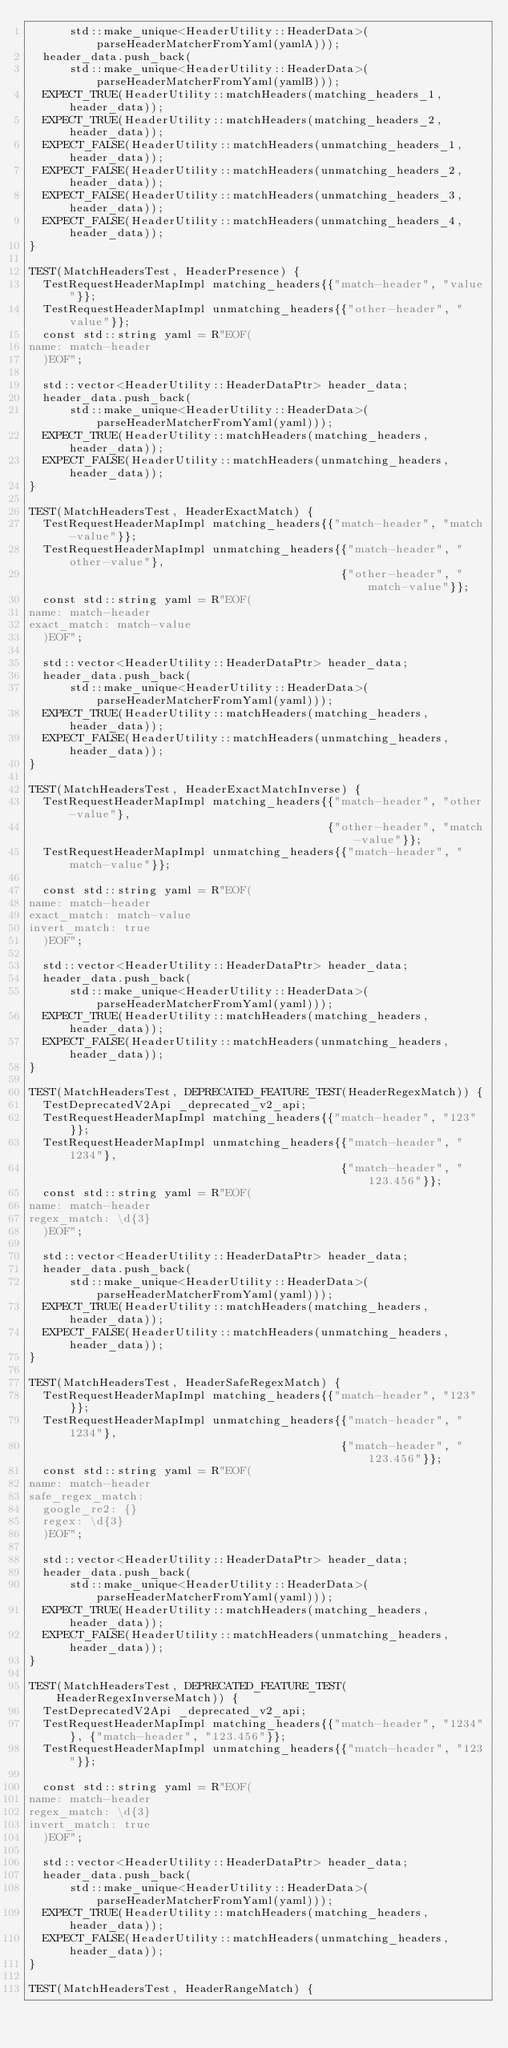Convert code to text. <code><loc_0><loc_0><loc_500><loc_500><_C++_>      std::make_unique<HeaderUtility::HeaderData>(parseHeaderMatcherFromYaml(yamlA)));
  header_data.push_back(
      std::make_unique<HeaderUtility::HeaderData>(parseHeaderMatcherFromYaml(yamlB)));
  EXPECT_TRUE(HeaderUtility::matchHeaders(matching_headers_1, header_data));
  EXPECT_TRUE(HeaderUtility::matchHeaders(matching_headers_2, header_data));
  EXPECT_FALSE(HeaderUtility::matchHeaders(unmatching_headers_1, header_data));
  EXPECT_FALSE(HeaderUtility::matchHeaders(unmatching_headers_2, header_data));
  EXPECT_FALSE(HeaderUtility::matchHeaders(unmatching_headers_3, header_data));
  EXPECT_FALSE(HeaderUtility::matchHeaders(unmatching_headers_4, header_data));
}

TEST(MatchHeadersTest, HeaderPresence) {
  TestRequestHeaderMapImpl matching_headers{{"match-header", "value"}};
  TestRequestHeaderMapImpl unmatching_headers{{"other-header", "value"}};
  const std::string yaml = R"EOF(
name: match-header
  )EOF";

  std::vector<HeaderUtility::HeaderDataPtr> header_data;
  header_data.push_back(
      std::make_unique<HeaderUtility::HeaderData>(parseHeaderMatcherFromYaml(yaml)));
  EXPECT_TRUE(HeaderUtility::matchHeaders(matching_headers, header_data));
  EXPECT_FALSE(HeaderUtility::matchHeaders(unmatching_headers, header_data));
}

TEST(MatchHeadersTest, HeaderExactMatch) {
  TestRequestHeaderMapImpl matching_headers{{"match-header", "match-value"}};
  TestRequestHeaderMapImpl unmatching_headers{{"match-header", "other-value"},
                                              {"other-header", "match-value"}};
  const std::string yaml = R"EOF(
name: match-header
exact_match: match-value
  )EOF";

  std::vector<HeaderUtility::HeaderDataPtr> header_data;
  header_data.push_back(
      std::make_unique<HeaderUtility::HeaderData>(parseHeaderMatcherFromYaml(yaml)));
  EXPECT_TRUE(HeaderUtility::matchHeaders(matching_headers, header_data));
  EXPECT_FALSE(HeaderUtility::matchHeaders(unmatching_headers, header_data));
}

TEST(MatchHeadersTest, HeaderExactMatchInverse) {
  TestRequestHeaderMapImpl matching_headers{{"match-header", "other-value"},
                                            {"other-header", "match-value"}};
  TestRequestHeaderMapImpl unmatching_headers{{"match-header", "match-value"}};

  const std::string yaml = R"EOF(
name: match-header
exact_match: match-value
invert_match: true
  )EOF";

  std::vector<HeaderUtility::HeaderDataPtr> header_data;
  header_data.push_back(
      std::make_unique<HeaderUtility::HeaderData>(parseHeaderMatcherFromYaml(yaml)));
  EXPECT_TRUE(HeaderUtility::matchHeaders(matching_headers, header_data));
  EXPECT_FALSE(HeaderUtility::matchHeaders(unmatching_headers, header_data));
}

TEST(MatchHeadersTest, DEPRECATED_FEATURE_TEST(HeaderRegexMatch)) {
  TestDeprecatedV2Api _deprecated_v2_api;
  TestRequestHeaderMapImpl matching_headers{{"match-header", "123"}};
  TestRequestHeaderMapImpl unmatching_headers{{"match-header", "1234"},
                                              {"match-header", "123.456"}};
  const std::string yaml = R"EOF(
name: match-header
regex_match: \d{3}
  )EOF";

  std::vector<HeaderUtility::HeaderDataPtr> header_data;
  header_data.push_back(
      std::make_unique<HeaderUtility::HeaderData>(parseHeaderMatcherFromYaml(yaml)));
  EXPECT_TRUE(HeaderUtility::matchHeaders(matching_headers, header_data));
  EXPECT_FALSE(HeaderUtility::matchHeaders(unmatching_headers, header_data));
}

TEST(MatchHeadersTest, HeaderSafeRegexMatch) {
  TestRequestHeaderMapImpl matching_headers{{"match-header", "123"}};
  TestRequestHeaderMapImpl unmatching_headers{{"match-header", "1234"},
                                              {"match-header", "123.456"}};
  const std::string yaml = R"EOF(
name: match-header
safe_regex_match:
  google_re2: {}
  regex: \d{3}
  )EOF";

  std::vector<HeaderUtility::HeaderDataPtr> header_data;
  header_data.push_back(
      std::make_unique<HeaderUtility::HeaderData>(parseHeaderMatcherFromYaml(yaml)));
  EXPECT_TRUE(HeaderUtility::matchHeaders(matching_headers, header_data));
  EXPECT_FALSE(HeaderUtility::matchHeaders(unmatching_headers, header_data));
}

TEST(MatchHeadersTest, DEPRECATED_FEATURE_TEST(HeaderRegexInverseMatch)) {
  TestDeprecatedV2Api _deprecated_v2_api;
  TestRequestHeaderMapImpl matching_headers{{"match-header", "1234"}, {"match-header", "123.456"}};
  TestRequestHeaderMapImpl unmatching_headers{{"match-header", "123"}};

  const std::string yaml = R"EOF(
name: match-header
regex_match: \d{3}
invert_match: true
  )EOF";

  std::vector<HeaderUtility::HeaderDataPtr> header_data;
  header_data.push_back(
      std::make_unique<HeaderUtility::HeaderData>(parseHeaderMatcherFromYaml(yaml)));
  EXPECT_TRUE(HeaderUtility::matchHeaders(matching_headers, header_data));
  EXPECT_FALSE(HeaderUtility::matchHeaders(unmatching_headers, header_data));
}

TEST(MatchHeadersTest, HeaderRangeMatch) {</code> 